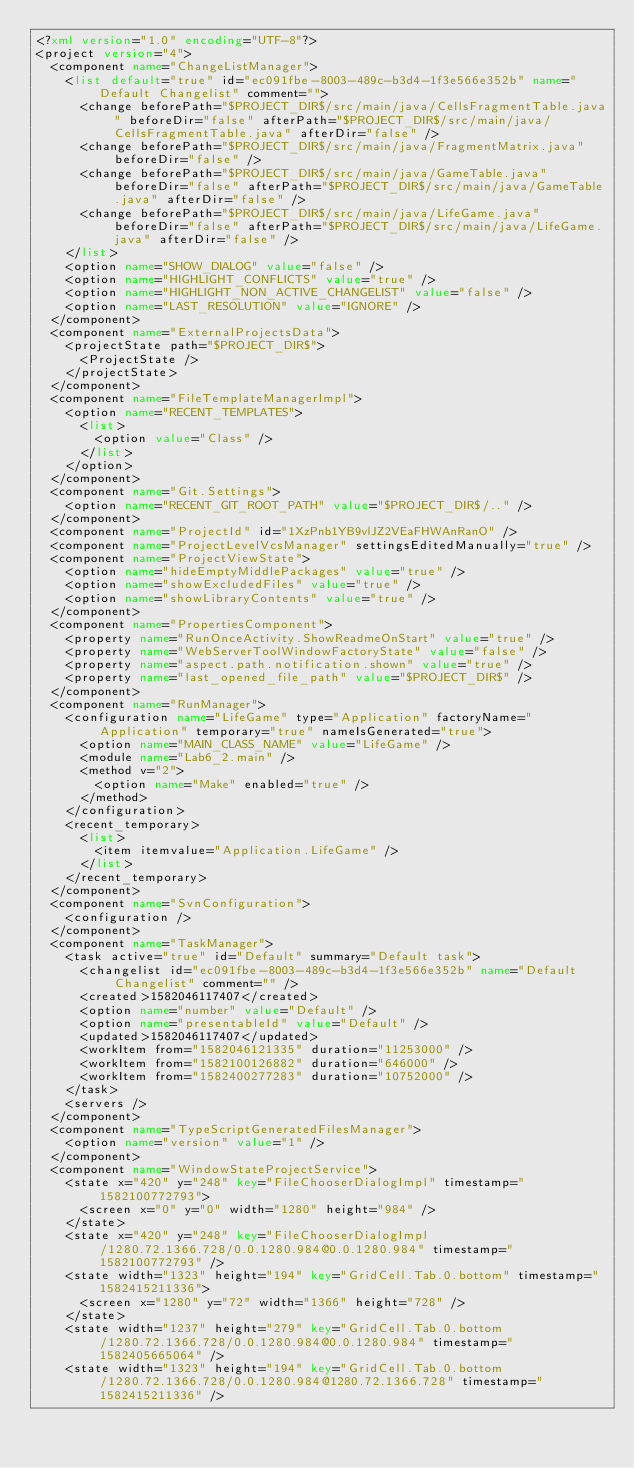<code> <loc_0><loc_0><loc_500><loc_500><_XML_><?xml version="1.0" encoding="UTF-8"?>
<project version="4">
  <component name="ChangeListManager">
    <list default="true" id="ec091fbe-8003-489c-b3d4-1f3e566e352b" name="Default Changelist" comment="">
      <change beforePath="$PROJECT_DIR$/src/main/java/CellsFragmentTable.java" beforeDir="false" afterPath="$PROJECT_DIR$/src/main/java/CellsFragmentTable.java" afterDir="false" />
      <change beforePath="$PROJECT_DIR$/src/main/java/FragmentMatrix.java" beforeDir="false" />
      <change beforePath="$PROJECT_DIR$/src/main/java/GameTable.java" beforeDir="false" afterPath="$PROJECT_DIR$/src/main/java/GameTable.java" afterDir="false" />
      <change beforePath="$PROJECT_DIR$/src/main/java/LifeGame.java" beforeDir="false" afterPath="$PROJECT_DIR$/src/main/java/LifeGame.java" afterDir="false" />
    </list>
    <option name="SHOW_DIALOG" value="false" />
    <option name="HIGHLIGHT_CONFLICTS" value="true" />
    <option name="HIGHLIGHT_NON_ACTIVE_CHANGELIST" value="false" />
    <option name="LAST_RESOLUTION" value="IGNORE" />
  </component>
  <component name="ExternalProjectsData">
    <projectState path="$PROJECT_DIR$">
      <ProjectState />
    </projectState>
  </component>
  <component name="FileTemplateManagerImpl">
    <option name="RECENT_TEMPLATES">
      <list>
        <option value="Class" />
      </list>
    </option>
  </component>
  <component name="Git.Settings">
    <option name="RECENT_GIT_ROOT_PATH" value="$PROJECT_DIR$/.." />
  </component>
  <component name="ProjectId" id="1XzPnb1YB9vlJZ2VEaFHWAnRanO" />
  <component name="ProjectLevelVcsManager" settingsEditedManually="true" />
  <component name="ProjectViewState">
    <option name="hideEmptyMiddlePackages" value="true" />
    <option name="showExcludedFiles" value="true" />
    <option name="showLibraryContents" value="true" />
  </component>
  <component name="PropertiesComponent">
    <property name="RunOnceActivity.ShowReadmeOnStart" value="true" />
    <property name="WebServerToolWindowFactoryState" value="false" />
    <property name="aspect.path.notification.shown" value="true" />
    <property name="last_opened_file_path" value="$PROJECT_DIR$" />
  </component>
  <component name="RunManager">
    <configuration name="LifeGame" type="Application" factoryName="Application" temporary="true" nameIsGenerated="true">
      <option name="MAIN_CLASS_NAME" value="LifeGame" />
      <module name="Lab6_2.main" />
      <method v="2">
        <option name="Make" enabled="true" />
      </method>
    </configuration>
    <recent_temporary>
      <list>
        <item itemvalue="Application.LifeGame" />
      </list>
    </recent_temporary>
  </component>
  <component name="SvnConfiguration">
    <configuration />
  </component>
  <component name="TaskManager">
    <task active="true" id="Default" summary="Default task">
      <changelist id="ec091fbe-8003-489c-b3d4-1f3e566e352b" name="Default Changelist" comment="" />
      <created>1582046117407</created>
      <option name="number" value="Default" />
      <option name="presentableId" value="Default" />
      <updated>1582046117407</updated>
      <workItem from="1582046121335" duration="11253000" />
      <workItem from="1582100126882" duration="646000" />
      <workItem from="1582400277283" duration="10752000" />
    </task>
    <servers />
  </component>
  <component name="TypeScriptGeneratedFilesManager">
    <option name="version" value="1" />
  </component>
  <component name="WindowStateProjectService">
    <state x="420" y="248" key="FileChooserDialogImpl" timestamp="1582100772793">
      <screen x="0" y="0" width="1280" height="984" />
    </state>
    <state x="420" y="248" key="FileChooserDialogImpl/1280.72.1366.728/0.0.1280.984@0.0.1280.984" timestamp="1582100772793" />
    <state width="1323" height="194" key="GridCell.Tab.0.bottom" timestamp="1582415211336">
      <screen x="1280" y="72" width="1366" height="728" />
    </state>
    <state width="1237" height="279" key="GridCell.Tab.0.bottom/1280.72.1366.728/0.0.1280.984@0.0.1280.984" timestamp="1582405665064" />
    <state width="1323" height="194" key="GridCell.Tab.0.bottom/1280.72.1366.728/0.0.1280.984@1280.72.1366.728" timestamp="1582415211336" /></code> 